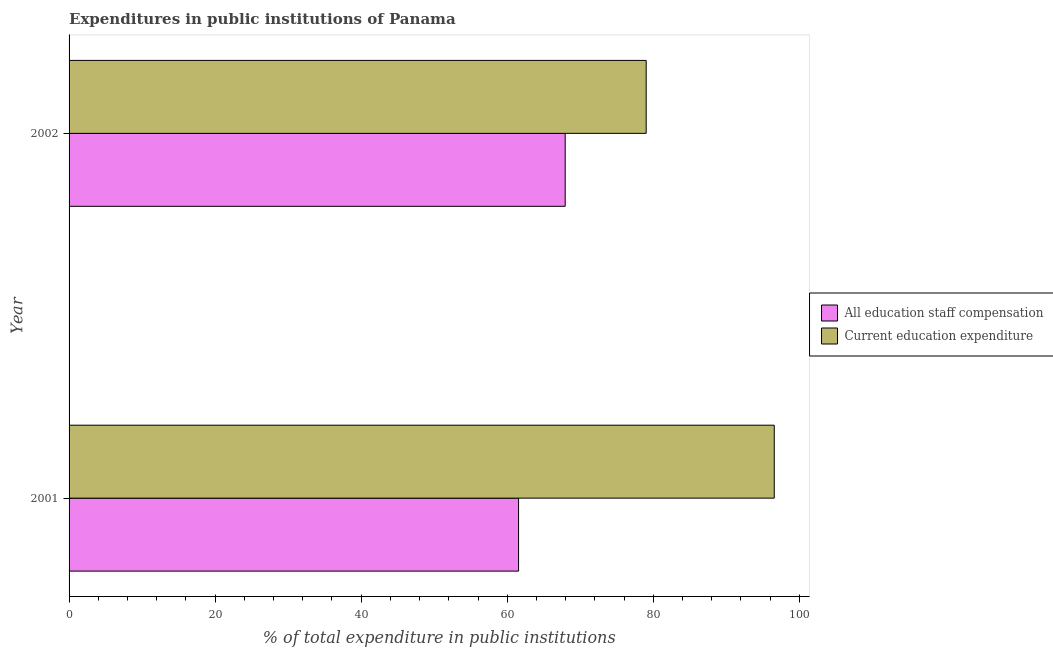How many different coloured bars are there?
Ensure brevity in your answer.  2. Are the number of bars on each tick of the Y-axis equal?
Your answer should be compact. Yes. How many bars are there on the 1st tick from the top?
Ensure brevity in your answer.  2. What is the label of the 2nd group of bars from the top?
Ensure brevity in your answer.  2001. What is the expenditure in staff compensation in 2002?
Your answer should be compact. 67.94. Across all years, what is the maximum expenditure in staff compensation?
Offer a terse response. 67.94. Across all years, what is the minimum expenditure in staff compensation?
Provide a succinct answer. 61.55. In which year was the expenditure in education maximum?
Make the answer very short. 2001. What is the total expenditure in staff compensation in the graph?
Give a very brief answer. 129.49. What is the difference between the expenditure in education in 2001 and that in 2002?
Your answer should be compact. 17.54. What is the difference between the expenditure in education in 2002 and the expenditure in staff compensation in 2001?
Provide a short and direct response. 17.48. What is the average expenditure in staff compensation per year?
Your answer should be very brief. 64.75. In the year 2001, what is the difference between the expenditure in education and expenditure in staff compensation?
Ensure brevity in your answer.  35.02. In how many years, is the expenditure in education greater than 20 %?
Make the answer very short. 2. What is the ratio of the expenditure in education in 2001 to that in 2002?
Ensure brevity in your answer.  1.22. Is the difference between the expenditure in education in 2001 and 2002 greater than the difference between the expenditure in staff compensation in 2001 and 2002?
Your answer should be compact. Yes. In how many years, is the expenditure in staff compensation greater than the average expenditure in staff compensation taken over all years?
Give a very brief answer. 1. What does the 1st bar from the top in 2001 represents?
Offer a terse response. Current education expenditure. What does the 1st bar from the bottom in 2001 represents?
Your answer should be compact. All education staff compensation. How many bars are there?
Offer a very short reply. 4. What is the difference between two consecutive major ticks on the X-axis?
Provide a short and direct response. 20. What is the title of the graph?
Your answer should be very brief. Expenditures in public institutions of Panama. What is the label or title of the X-axis?
Offer a very short reply. % of total expenditure in public institutions. What is the label or title of the Y-axis?
Keep it short and to the point. Year. What is the % of total expenditure in public institutions in All education staff compensation in 2001?
Your answer should be very brief. 61.55. What is the % of total expenditure in public institutions of Current education expenditure in 2001?
Offer a very short reply. 96.57. What is the % of total expenditure in public institutions of All education staff compensation in 2002?
Provide a succinct answer. 67.94. What is the % of total expenditure in public institutions in Current education expenditure in 2002?
Your answer should be compact. 79.03. Across all years, what is the maximum % of total expenditure in public institutions in All education staff compensation?
Keep it short and to the point. 67.94. Across all years, what is the maximum % of total expenditure in public institutions in Current education expenditure?
Provide a succinct answer. 96.57. Across all years, what is the minimum % of total expenditure in public institutions of All education staff compensation?
Give a very brief answer. 61.55. Across all years, what is the minimum % of total expenditure in public institutions of Current education expenditure?
Make the answer very short. 79.03. What is the total % of total expenditure in public institutions in All education staff compensation in the graph?
Provide a succinct answer. 129.49. What is the total % of total expenditure in public institutions in Current education expenditure in the graph?
Provide a succinct answer. 175.6. What is the difference between the % of total expenditure in public institutions of All education staff compensation in 2001 and that in 2002?
Keep it short and to the point. -6.39. What is the difference between the % of total expenditure in public institutions of Current education expenditure in 2001 and that in 2002?
Your answer should be compact. 17.54. What is the difference between the % of total expenditure in public institutions of All education staff compensation in 2001 and the % of total expenditure in public institutions of Current education expenditure in 2002?
Offer a terse response. -17.48. What is the average % of total expenditure in public institutions of All education staff compensation per year?
Offer a terse response. 64.75. What is the average % of total expenditure in public institutions of Current education expenditure per year?
Ensure brevity in your answer.  87.8. In the year 2001, what is the difference between the % of total expenditure in public institutions of All education staff compensation and % of total expenditure in public institutions of Current education expenditure?
Make the answer very short. -35.02. In the year 2002, what is the difference between the % of total expenditure in public institutions in All education staff compensation and % of total expenditure in public institutions in Current education expenditure?
Your answer should be very brief. -11.09. What is the ratio of the % of total expenditure in public institutions of All education staff compensation in 2001 to that in 2002?
Make the answer very short. 0.91. What is the ratio of the % of total expenditure in public institutions in Current education expenditure in 2001 to that in 2002?
Provide a short and direct response. 1.22. What is the difference between the highest and the second highest % of total expenditure in public institutions of All education staff compensation?
Offer a terse response. 6.39. What is the difference between the highest and the second highest % of total expenditure in public institutions in Current education expenditure?
Give a very brief answer. 17.54. What is the difference between the highest and the lowest % of total expenditure in public institutions in All education staff compensation?
Give a very brief answer. 6.39. What is the difference between the highest and the lowest % of total expenditure in public institutions of Current education expenditure?
Ensure brevity in your answer.  17.54. 